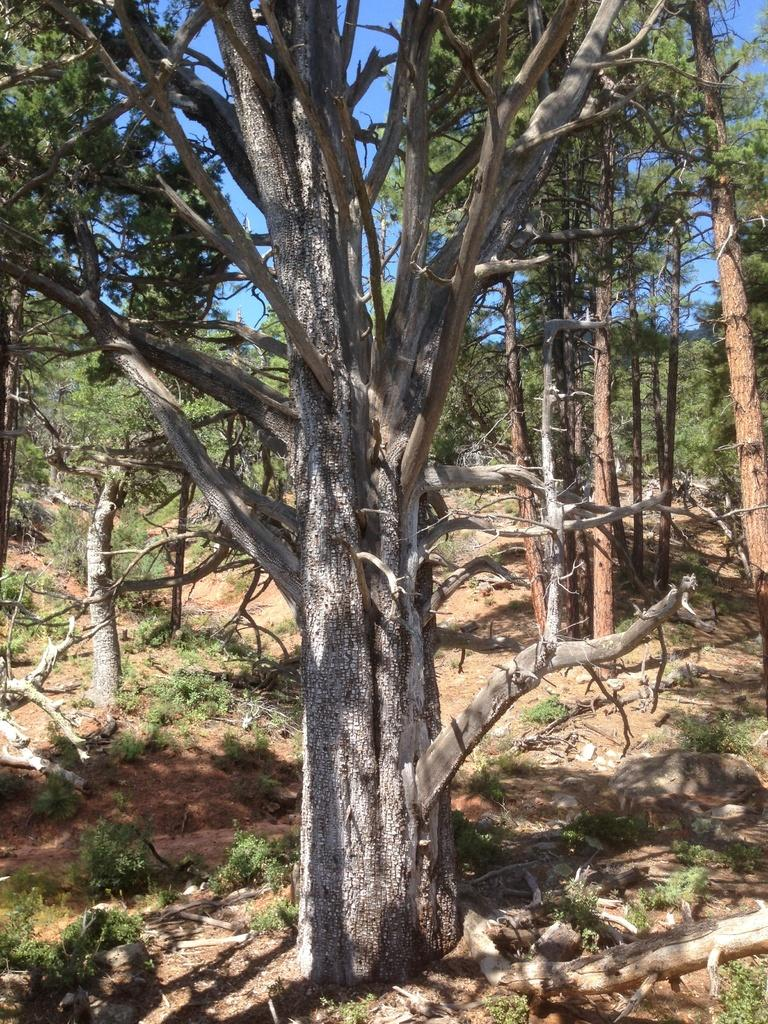What type of vegetation can be seen in the image? There are trees and plants in the image. What part of the natural environment is visible in the image? The sky is visible in the background of the image. Who is the owner of the wire in the image? There is no wire present in the image, so it is not possible to determine the owner. 